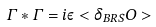Convert formula to latex. <formula><loc_0><loc_0><loc_500><loc_500>\Gamma * \Gamma = i \varepsilon < \delta _ { B R S } O ></formula> 